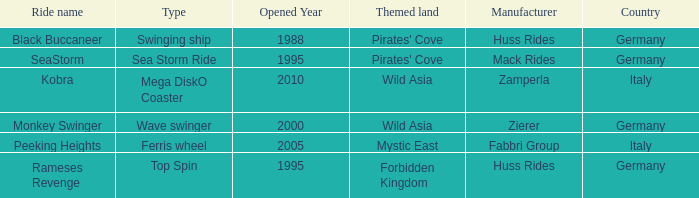What ride was manufactured by Zierer? Monkey Swinger. 